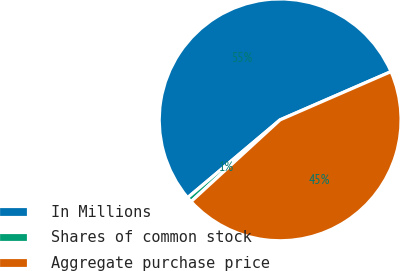Convert chart. <chart><loc_0><loc_0><loc_500><loc_500><pie_chart><fcel>In Millions<fcel>Shares of common stock<fcel>Aggregate purchase price<nl><fcel>54.6%<fcel>0.69%<fcel>44.71%<nl></chart> 